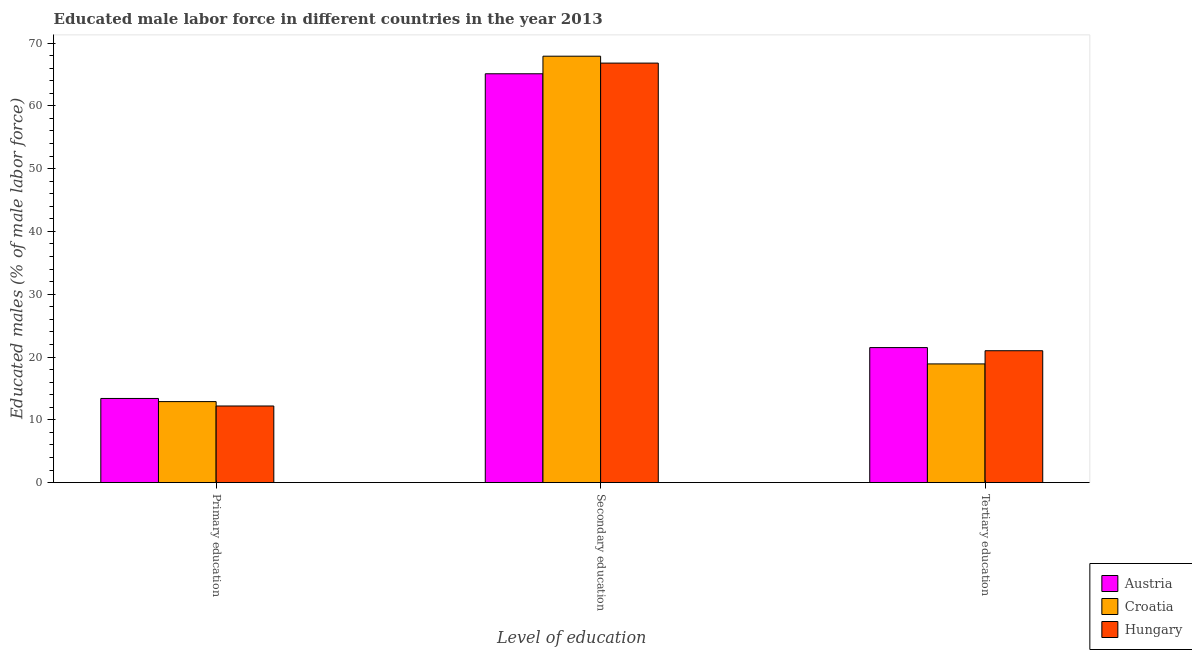Are the number of bars per tick equal to the number of legend labels?
Your answer should be compact. Yes. Are the number of bars on each tick of the X-axis equal?
Provide a succinct answer. Yes. How many bars are there on the 1st tick from the right?
Keep it short and to the point. 3. What is the label of the 2nd group of bars from the left?
Give a very brief answer. Secondary education. What is the percentage of male labor force who received secondary education in Hungary?
Provide a succinct answer. 66.8. Across all countries, what is the maximum percentage of male labor force who received primary education?
Offer a terse response. 13.4. Across all countries, what is the minimum percentage of male labor force who received tertiary education?
Offer a terse response. 18.9. In which country was the percentage of male labor force who received secondary education maximum?
Make the answer very short. Croatia. In which country was the percentage of male labor force who received tertiary education minimum?
Your answer should be compact. Croatia. What is the total percentage of male labor force who received tertiary education in the graph?
Provide a succinct answer. 61.4. What is the difference between the percentage of male labor force who received tertiary education in Croatia and that in Hungary?
Your answer should be very brief. -2.1. What is the difference between the percentage of male labor force who received primary education in Hungary and the percentage of male labor force who received tertiary education in Austria?
Keep it short and to the point. -9.3. What is the average percentage of male labor force who received secondary education per country?
Your answer should be very brief. 66.6. What is the difference between the percentage of male labor force who received tertiary education and percentage of male labor force who received secondary education in Hungary?
Keep it short and to the point. -45.8. In how many countries, is the percentage of male labor force who received primary education greater than 20 %?
Ensure brevity in your answer.  0. What is the ratio of the percentage of male labor force who received tertiary education in Hungary to that in Croatia?
Offer a terse response. 1.11. What is the difference between the highest and the second highest percentage of male labor force who received secondary education?
Ensure brevity in your answer.  1.1. What is the difference between the highest and the lowest percentage of male labor force who received tertiary education?
Make the answer very short. 2.6. Is the sum of the percentage of male labor force who received secondary education in Croatia and Austria greater than the maximum percentage of male labor force who received tertiary education across all countries?
Keep it short and to the point. Yes. What does the 3rd bar from the left in Primary education represents?
Provide a short and direct response. Hungary. What does the 1st bar from the right in Tertiary education represents?
Give a very brief answer. Hungary. How many bars are there?
Provide a short and direct response. 9. How many countries are there in the graph?
Give a very brief answer. 3. What is the difference between two consecutive major ticks on the Y-axis?
Your answer should be very brief. 10. Are the values on the major ticks of Y-axis written in scientific E-notation?
Your answer should be compact. No. Does the graph contain any zero values?
Offer a terse response. No. Does the graph contain grids?
Provide a short and direct response. No. Where does the legend appear in the graph?
Give a very brief answer. Bottom right. How many legend labels are there?
Offer a very short reply. 3. How are the legend labels stacked?
Ensure brevity in your answer.  Vertical. What is the title of the graph?
Keep it short and to the point. Educated male labor force in different countries in the year 2013. Does "Lao PDR" appear as one of the legend labels in the graph?
Provide a succinct answer. No. What is the label or title of the X-axis?
Keep it short and to the point. Level of education. What is the label or title of the Y-axis?
Offer a very short reply. Educated males (% of male labor force). What is the Educated males (% of male labor force) of Austria in Primary education?
Offer a terse response. 13.4. What is the Educated males (% of male labor force) of Croatia in Primary education?
Your response must be concise. 12.9. What is the Educated males (% of male labor force) in Hungary in Primary education?
Ensure brevity in your answer.  12.2. What is the Educated males (% of male labor force) of Austria in Secondary education?
Offer a very short reply. 65.1. What is the Educated males (% of male labor force) in Croatia in Secondary education?
Give a very brief answer. 67.9. What is the Educated males (% of male labor force) of Hungary in Secondary education?
Provide a short and direct response. 66.8. What is the Educated males (% of male labor force) in Austria in Tertiary education?
Offer a terse response. 21.5. What is the Educated males (% of male labor force) in Croatia in Tertiary education?
Your response must be concise. 18.9. What is the Educated males (% of male labor force) of Hungary in Tertiary education?
Your response must be concise. 21. Across all Level of education, what is the maximum Educated males (% of male labor force) in Austria?
Provide a succinct answer. 65.1. Across all Level of education, what is the maximum Educated males (% of male labor force) in Croatia?
Make the answer very short. 67.9. Across all Level of education, what is the maximum Educated males (% of male labor force) of Hungary?
Make the answer very short. 66.8. Across all Level of education, what is the minimum Educated males (% of male labor force) in Austria?
Provide a succinct answer. 13.4. Across all Level of education, what is the minimum Educated males (% of male labor force) of Croatia?
Your response must be concise. 12.9. Across all Level of education, what is the minimum Educated males (% of male labor force) in Hungary?
Offer a terse response. 12.2. What is the total Educated males (% of male labor force) in Austria in the graph?
Provide a succinct answer. 100. What is the total Educated males (% of male labor force) of Croatia in the graph?
Keep it short and to the point. 99.7. What is the difference between the Educated males (% of male labor force) in Austria in Primary education and that in Secondary education?
Offer a terse response. -51.7. What is the difference between the Educated males (% of male labor force) in Croatia in Primary education and that in Secondary education?
Your answer should be very brief. -55. What is the difference between the Educated males (% of male labor force) of Hungary in Primary education and that in Secondary education?
Give a very brief answer. -54.6. What is the difference between the Educated males (% of male labor force) in Austria in Primary education and that in Tertiary education?
Offer a very short reply. -8.1. What is the difference between the Educated males (% of male labor force) of Austria in Secondary education and that in Tertiary education?
Offer a terse response. 43.6. What is the difference between the Educated males (% of male labor force) in Croatia in Secondary education and that in Tertiary education?
Your answer should be compact. 49. What is the difference between the Educated males (% of male labor force) of Hungary in Secondary education and that in Tertiary education?
Provide a succinct answer. 45.8. What is the difference between the Educated males (% of male labor force) in Austria in Primary education and the Educated males (% of male labor force) in Croatia in Secondary education?
Keep it short and to the point. -54.5. What is the difference between the Educated males (% of male labor force) of Austria in Primary education and the Educated males (% of male labor force) of Hungary in Secondary education?
Give a very brief answer. -53.4. What is the difference between the Educated males (% of male labor force) of Croatia in Primary education and the Educated males (% of male labor force) of Hungary in Secondary education?
Keep it short and to the point. -53.9. What is the difference between the Educated males (% of male labor force) in Austria in Primary education and the Educated males (% of male labor force) in Croatia in Tertiary education?
Your answer should be very brief. -5.5. What is the difference between the Educated males (% of male labor force) of Austria in Primary education and the Educated males (% of male labor force) of Hungary in Tertiary education?
Your answer should be very brief. -7.6. What is the difference between the Educated males (% of male labor force) in Croatia in Primary education and the Educated males (% of male labor force) in Hungary in Tertiary education?
Make the answer very short. -8.1. What is the difference between the Educated males (% of male labor force) of Austria in Secondary education and the Educated males (% of male labor force) of Croatia in Tertiary education?
Provide a short and direct response. 46.2. What is the difference between the Educated males (% of male labor force) of Austria in Secondary education and the Educated males (% of male labor force) of Hungary in Tertiary education?
Ensure brevity in your answer.  44.1. What is the difference between the Educated males (% of male labor force) in Croatia in Secondary education and the Educated males (% of male labor force) in Hungary in Tertiary education?
Offer a very short reply. 46.9. What is the average Educated males (% of male labor force) in Austria per Level of education?
Provide a succinct answer. 33.33. What is the average Educated males (% of male labor force) of Croatia per Level of education?
Provide a short and direct response. 33.23. What is the average Educated males (% of male labor force) in Hungary per Level of education?
Make the answer very short. 33.33. What is the difference between the Educated males (% of male labor force) of Austria and Educated males (% of male labor force) of Hungary in Secondary education?
Ensure brevity in your answer.  -1.7. What is the difference between the Educated males (% of male labor force) of Austria and Educated males (% of male labor force) of Croatia in Tertiary education?
Your answer should be compact. 2.6. What is the difference between the Educated males (% of male labor force) of Croatia and Educated males (% of male labor force) of Hungary in Tertiary education?
Offer a very short reply. -2.1. What is the ratio of the Educated males (% of male labor force) of Austria in Primary education to that in Secondary education?
Your response must be concise. 0.21. What is the ratio of the Educated males (% of male labor force) of Croatia in Primary education to that in Secondary education?
Your answer should be very brief. 0.19. What is the ratio of the Educated males (% of male labor force) in Hungary in Primary education to that in Secondary education?
Your response must be concise. 0.18. What is the ratio of the Educated males (% of male labor force) of Austria in Primary education to that in Tertiary education?
Give a very brief answer. 0.62. What is the ratio of the Educated males (% of male labor force) in Croatia in Primary education to that in Tertiary education?
Provide a succinct answer. 0.68. What is the ratio of the Educated males (% of male labor force) of Hungary in Primary education to that in Tertiary education?
Make the answer very short. 0.58. What is the ratio of the Educated males (% of male labor force) in Austria in Secondary education to that in Tertiary education?
Make the answer very short. 3.03. What is the ratio of the Educated males (% of male labor force) of Croatia in Secondary education to that in Tertiary education?
Offer a terse response. 3.59. What is the ratio of the Educated males (% of male labor force) of Hungary in Secondary education to that in Tertiary education?
Make the answer very short. 3.18. What is the difference between the highest and the second highest Educated males (% of male labor force) in Austria?
Keep it short and to the point. 43.6. What is the difference between the highest and the second highest Educated males (% of male labor force) of Croatia?
Keep it short and to the point. 49. What is the difference between the highest and the second highest Educated males (% of male labor force) in Hungary?
Your response must be concise. 45.8. What is the difference between the highest and the lowest Educated males (% of male labor force) in Austria?
Provide a succinct answer. 51.7. What is the difference between the highest and the lowest Educated males (% of male labor force) in Hungary?
Make the answer very short. 54.6. 